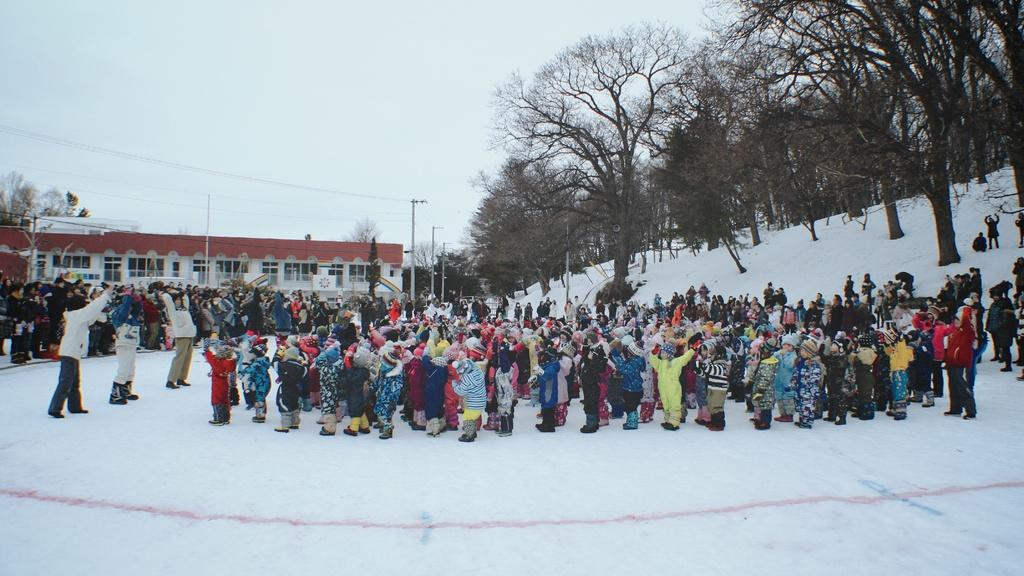What structure is located on the left side of the image? There is a house on the left side of the image. What type of vegetation is on the left side of the image? There are many trees on the left side of the image. What can be seen in the middle of the image? There are many people in the middle of the image. What is visible in the background of the image? The sky is visible in the background of the image. Where are the horses located in the image? There are no horses present in the image. What type of furniture can be seen in the image? There is no furniture, such as a sofa, present in the image. 